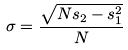<formula> <loc_0><loc_0><loc_500><loc_500>\sigma = \frac { \sqrt { N s _ { 2 } - s _ { 1 } ^ { 2 } } } { N }</formula> 